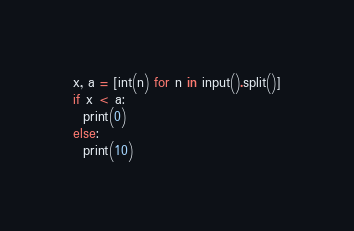<code> <loc_0><loc_0><loc_500><loc_500><_Python_>x, a = [int(n) for n in input().split()]
if x < a:
  print(0)
else:
  print(10)</code> 